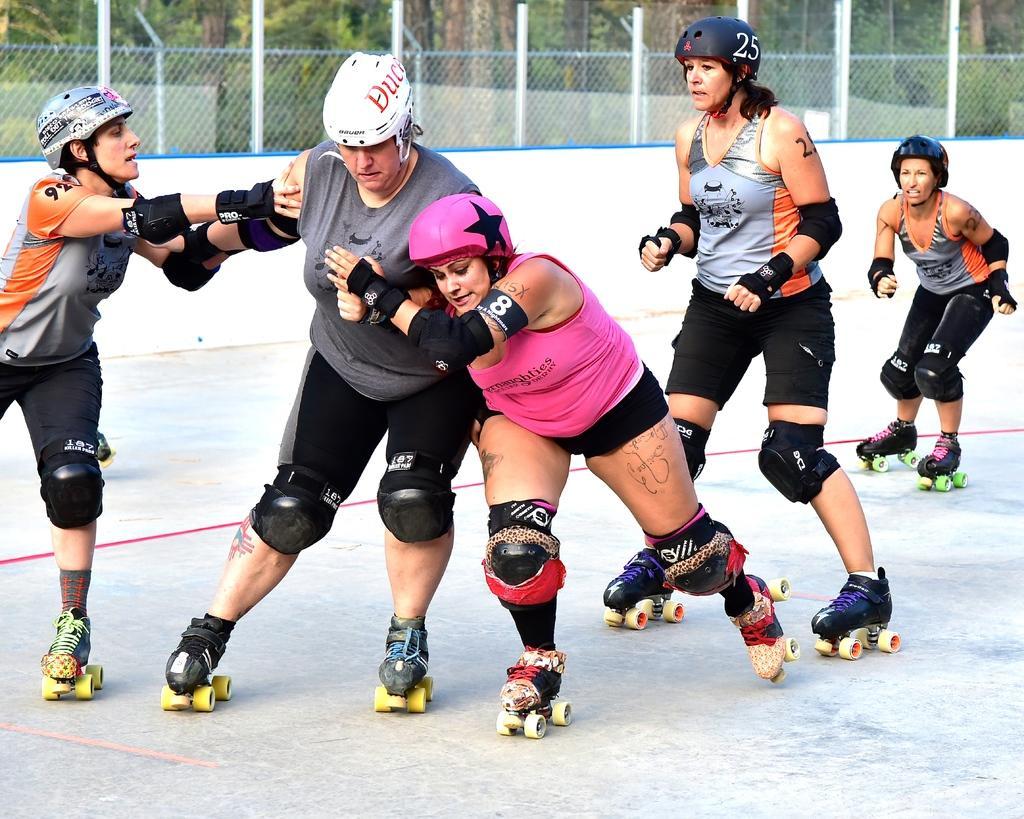Can you describe this image briefly? In this image, we can see people wearing roller skates and in the background, there are trees and we can see a fence. At the bottom, there is ground. 